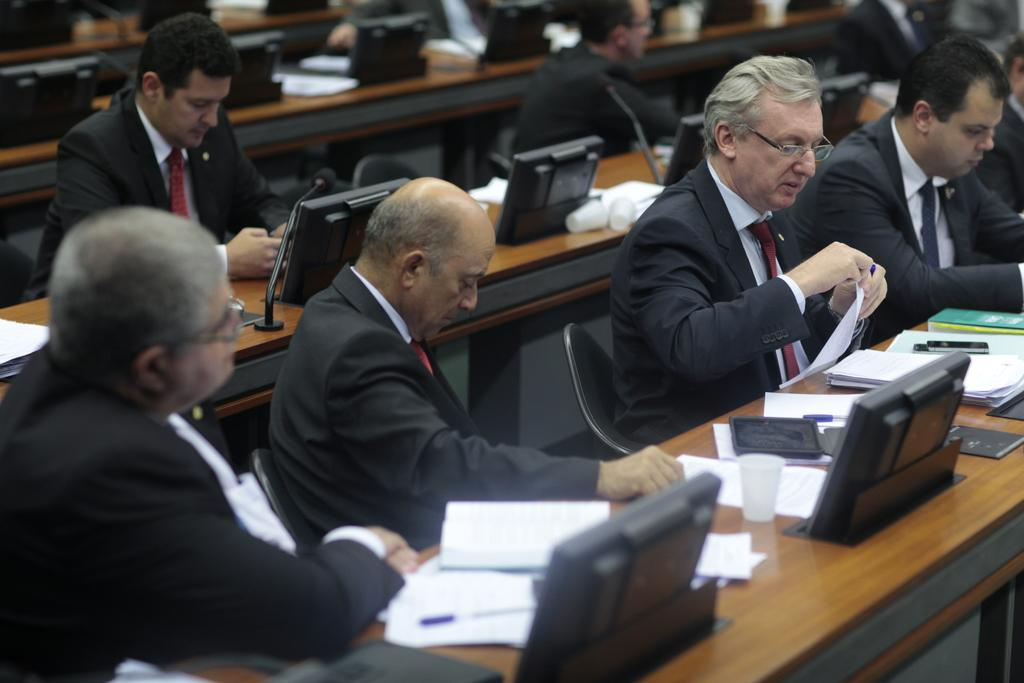What are the people in the image doing? The people in the image are sitting on chairs. What can be seen on the table in the image? There are laptops, glasses, and papers on the table. How many tables are visible in the image? There is at least one table visible in the image. What type of pancake is being served on the table in the image? There is no pancake present on the table in the image. What agreement was reached during the meeting depicted in the image? There is no indication of a meeting or any agreements in the image. 